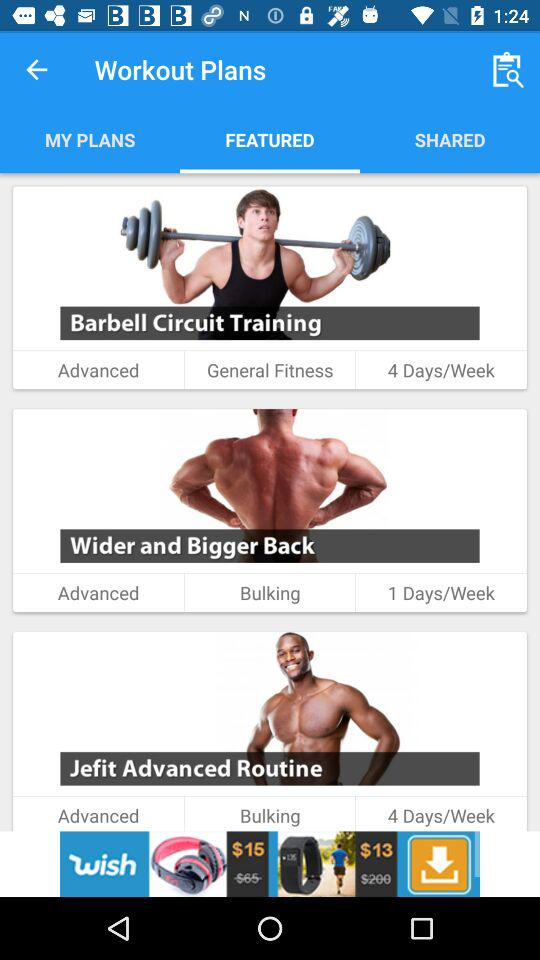What's the schedule of "Barbell Circuit Training"? The schedule is 4 days/week. 